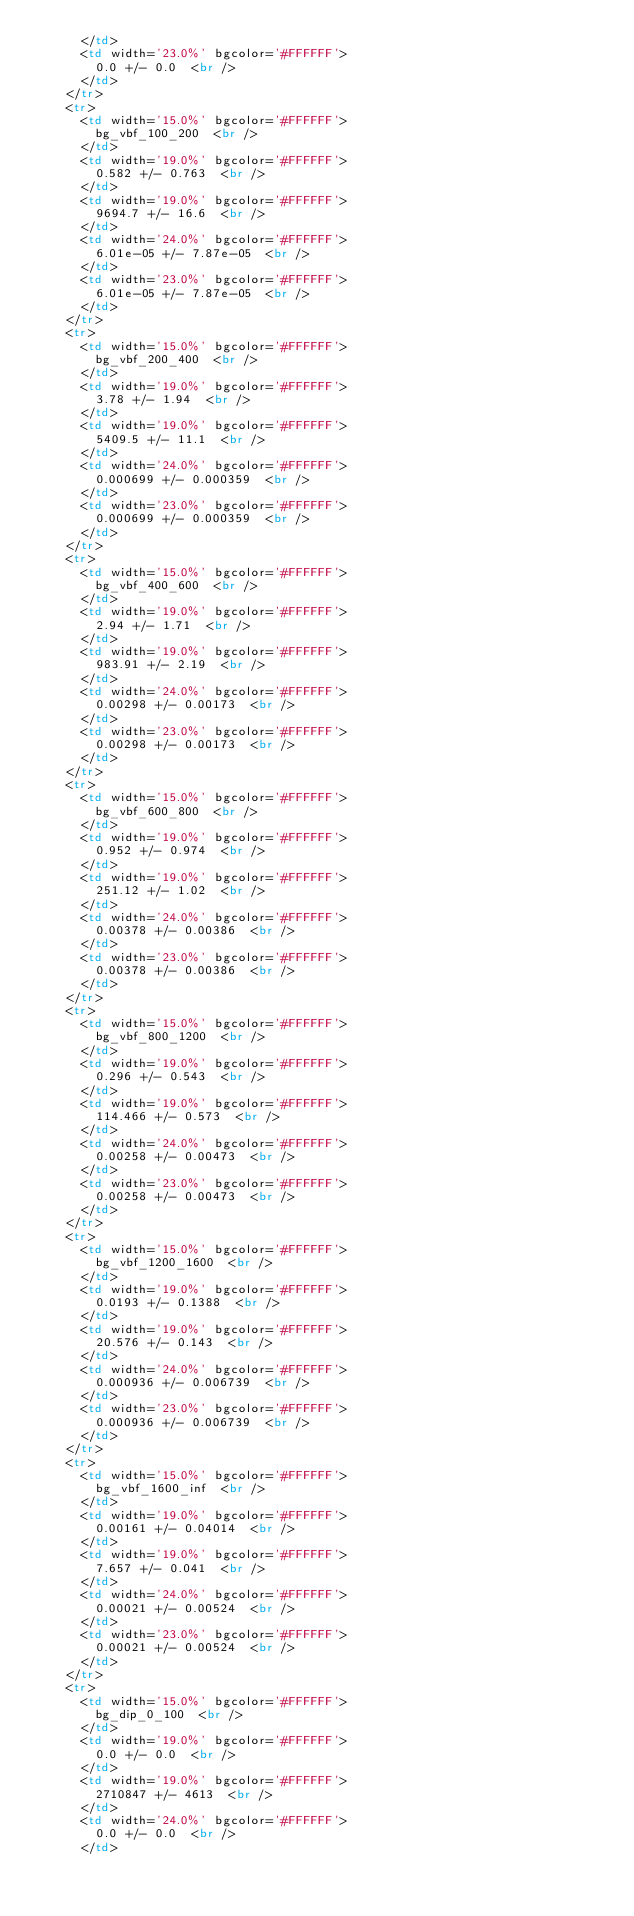Convert code to text. <code><loc_0><loc_0><loc_500><loc_500><_HTML_>      </td> 
      <td width='23.0%' bgcolor='#FFFFFF'>
        0.0 +/- 0.0  <br />
      </td>
    </tr>
    <tr>
      <td width='15.0%' bgcolor='#FFFFFF'>
        bg_vbf_100_200  <br />
      </td> 
      <td width='19.0%' bgcolor='#FFFFFF'>
        0.582 +/- 0.763  <br />
      </td> 
      <td width='19.0%' bgcolor='#FFFFFF'>
        9694.7 +/- 16.6  <br />
      </td> 
      <td width='24.0%' bgcolor='#FFFFFF'>
        6.01e-05 +/- 7.87e-05  <br />
      </td> 
      <td width='23.0%' bgcolor='#FFFFFF'>
        6.01e-05 +/- 7.87e-05  <br />
      </td>
    </tr>
    <tr>
      <td width='15.0%' bgcolor='#FFFFFF'>
        bg_vbf_200_400  <br />
      </td> 
      <td width='19.0%' bgcolor='#FFFFFF'>
        3.78 +/- 1.94  <br />
      </td> 
      <td width='19.0%' bgcolor='#FFFFFF'>
        5409.5 +/- 11.1  <br />
      </td> 
      <td width='24.0%' bgcolor='#FFFFFF'>
        0.000699 +/- 0.000359  <br />
      </td> 
      <td width='23.0%' bgcolor='#FFFFFF'>
        0.000699 +/- 0.000359  <br />
      </td>
    </tr>
    <tr>
      <td width='15.0%' bgcolor='#FFFFFF'>
        bg_vbf_400_600  <br />
      </td> 
      <td width='19.0%' bgcolor='#FFFFFF'>
        2.94 +/- 1.71  <br />
      </td> 
      <td width='19.0%' bgcolor='#FFFFFF'>
        983.91 +/- 2.19  <br />
      </td> 
      <td width='24.0%' bgcolor='#FFFFFF'>
        0.00298 +/- 0.00173  <br />
      </td> 
      <td width='23.0%' bgcolor='#FFFFFF'>
        0.00298 +/- 0.00173  <br />
      </td>
    </tr>
    <tr>
      <td width='15.0%' bgcolor='#FFFFFF'>
        bg_vbf_600_800  <br />
      </td> 
      <td width='19.0%' bgcolor='#FFFFFF'>
        0.952 +/- 0.974  <br />
      </td> 
      <td width='19.0%' bgcolor='#FFFFFF'>
        251.12 +/- 1.02  <br />
      </td> 
      <td width='24.0%' bgcolor='#FFFFFF'>
        0.00378 +/- 0.00386  <br />
      </td> 
      <td width='23.0%' bgcolor='#FFFFFF'>
        0.00378 +/- 0.00386  <br />
      </td>
    </tr>
    <tr>
      <td width='15.0%' bgcolor='#FFFFFF'>
        bg_vbf_800_1200  <br />
      </td> 
      <td width='19.0%' bgcolor='#FFFFFF'>
        0.296 +/- 0.543  <br />
      </td> 
      <td width='19.0%' bgcolor='#FFFFFF'>
        114.466 +/- 0.573  <br />
      </td> 
      <td width='24.0%' bgcolor='#FFFFFF'>
        0.00258 +/- 0.00473  <br />
      </td> 
      <td width='23.0%' bgcolor='#FFFFFF'>
        0.00258 +/- 0.00473  <br />
      </td>
    </tr>
    <tr>
      <td width='15.0%' bgcolor='#FFFFFF'>
        bg_vbf_1200_1600  <br />
      </td> 
      <td width='19.0%' bgcolor='#FFFFFF'>
        0.0193 +/- 0.1388  <br />
      </td> 
      <td width='19.0%' bgcolor='#FFFFFF'>
        20.576 +/- 0.143  <br />
      </td> 
      <td width='24.0%' bgcolor='#FFFFFF'>
        0.000936 +/- 0.006739  <br />
      </td> 
      <td width='23.0%' bgcolor='#FFFFFF'>
        0.000936 +/- 0.006739  <br />
      </td>
    </tr>
    <tr>
      <td width='15.0%' bgcolor='#FFFFFF'>
        bg_vbf_1600_inf  <br />
      </td> 
      <td width='19.0%' bgcolor='#FFFFFF'>
        0.00161 +/- 0.04014  <br />
      </td> 
      <td width='19.0%' bgcolor='#FFFFFF'>
        7.657 +/- 0.041  <br />
      </td> 
      <td width='24.0%' bgcolor='#FFFFFF'>
        0.00021 +/- 0.00524  <br />
      </td> 
      <td width='23.0%' bgcolor='#FFFFFF'>
        0.00021 +/- 0.00524  <br />
      </td>
    </tr>
    <tr>
      <td width='15.0%' bgcolor='#FFFFFF'>
        bg_dip_0_100  <br />
      </td> 
      <td width='19.0%' bgcolor='#FFFFFF'>
        0.0 +/- 0.0  <br />
      </td> 
      <td width='19.0%' bgcolor='#FFFFFF'>
        2710847 +/- 4613  <br />
      </td> 
      <td width='24.0%' bgcolor='#FFFFFF'>
        0.0 +/- 0.0  <br />
      </td> </code> 